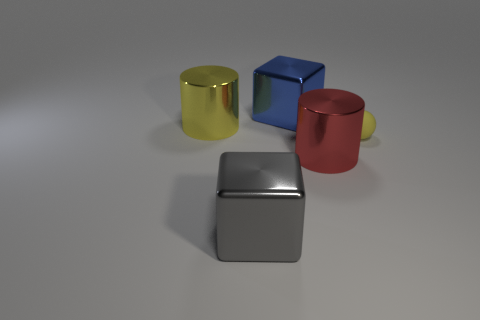Is there anything else that has the same size as the yellow matte thing?
Offer a terse response. No. Is there a shiny thing of the same color as the matte ball?
Give a very brief answer. Yes. How big is the yellow metallic thing?
Your answer should be very brief. Large. What number of objects are rubber balls or shiny things that are in front of the blue block?
Give a very brief answer. 4. There is a large blue thing on the right side of the big object that is in front of the big red thing; what number of small yellow rubber balls are right of it?
Provide a succinct answer. 1. What is the material of the cylinder that is the same color as the ball?
Provide a short and direct response. Metal. What number of brown rubber cylinders are there?
Give a very brief answer. 0. Does the shiny block in front of the yellow cylinder have the same size as the big yellow thing?
Offer a terse response. Yes. How many matte objects are big gray things or yellow cylinders?
Offer a terse response. 0. There is a large metal object that is left of the gray thing; what number of blue shiny objects are behind it?
Provide a short and direct response. 1. 